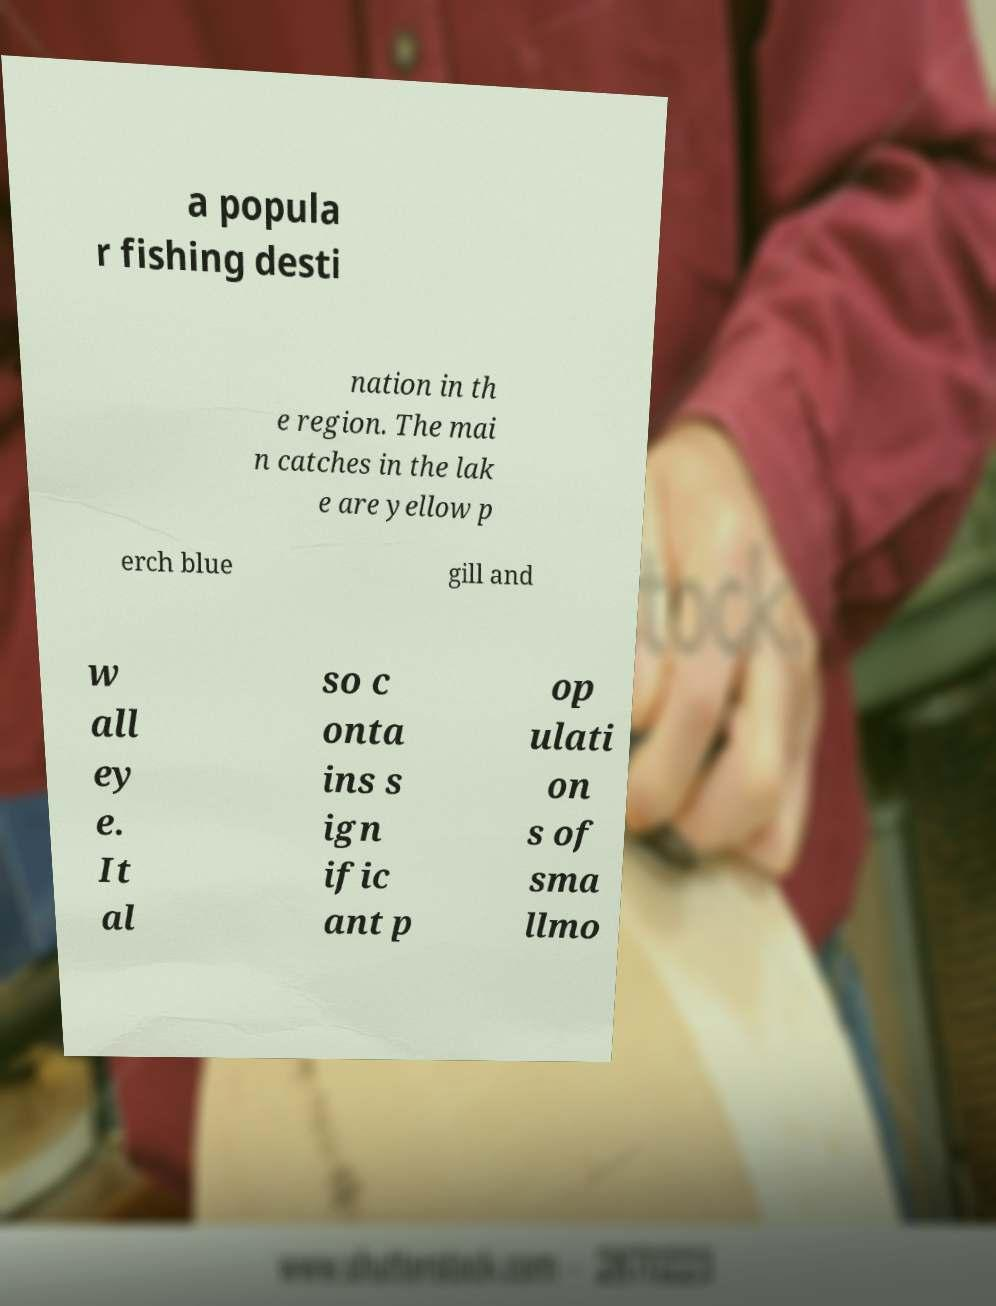Can you accurately transcribe the text from the provided image for me? a popula r fishing desti nation in th e region. The mai n catches in the lak e are yellow p erch blue gill and w all ey e. It al so c onta ins s ign ific ant p op ulati on s of sma llmo 